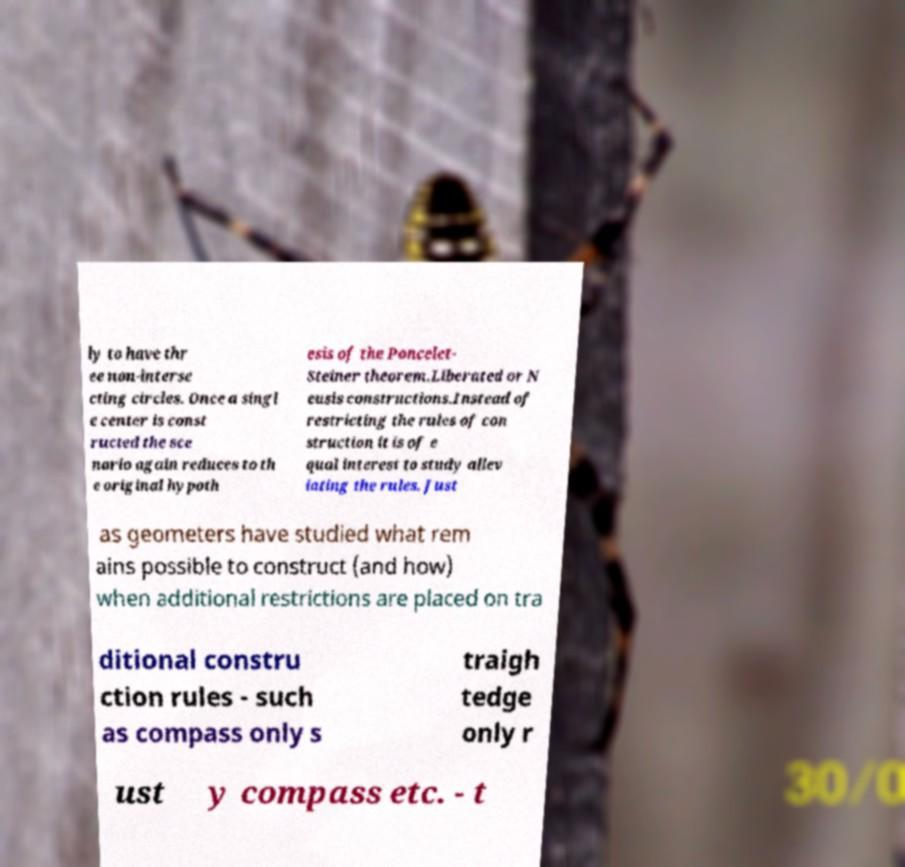Can you read and provide the text displayed in the image?This photo seems to have some interesting text. Can you extract and type it out for me? ly to have thr ee non-interse cting circles. Once a singl e center is const ructed the sce nario again reduces to th e original hypoth esis of the Poncelet- Steiner theorem.Liberated or N eusis constructions.Instead of restricting the rules of con struction it is of e qual interest to study allev iating the rules. Just as geometers have studied what rem ains possible to construct (and how) when additional restrictions are placed on tra ditional constru ction rules - such as compass only s traigh tedge only r ust y compass etc. - t 